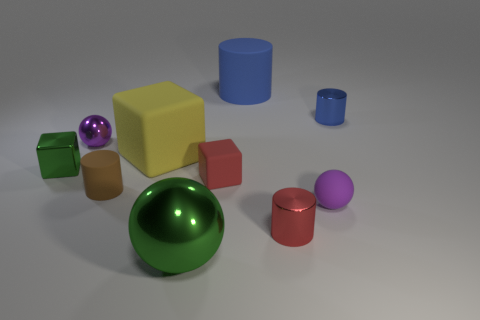Subtract all big blue cylinders. How many cylinders are left? 3 Subtract all brown cylinders. How many cylinders are left? 3 Subtract 3 cylinders. How many cylinders are left? 1 Subtract all cylinders. How many objects are left? 6 Subtract all purple cubes. How many green balls are left? 1 Add 6 large green shiny balls. How many large green shiny balls exist? 7 Subtract 0 yellow cylinders. How many objects are left? 10 Subtract all brown blocks. Subtract all blue cylinders. How many blocks are left? 3 Subtract all large purple matte spheres. Subtract all cylinders. How many objects are left? 6 Add 8 green shiny cubes. How many green shiny cubes are left? 9 